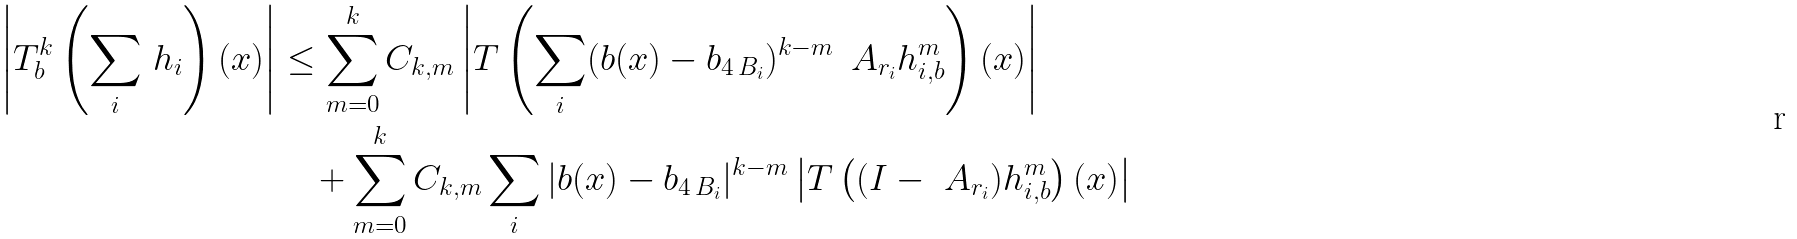Convert formula to latex. <formula><loc_0><loc_0><loc_500><loc_500>\left | T _ { b } ^ { k } \left ( \sum _ { i } \, h _ { i } \right ) ( x ) \right | & \leq \sum _ { m = 0 } ^ { k } C _ { k , m } \left | T \left ( \sum _ { i } ( b ( x ) - b _ { 4 \, B _ { i } } ) ^ { k - m } \, \ A _ { r _ { i } } h _ { i , b } ^ { m } \right ) ( x ) \right | \\ & \quad + \sum _ { m = 0 } ^ { k } C _ { k , m } \sum _ { i } | b ( x ) - b _ { 4 \, B _ { i } } | ^ { k - m } \left | T \left ( ( I - \ A _ { r _ { i } } ) h _ { i , b } ^ { m } \right ) ( x ) \right |</formula> 